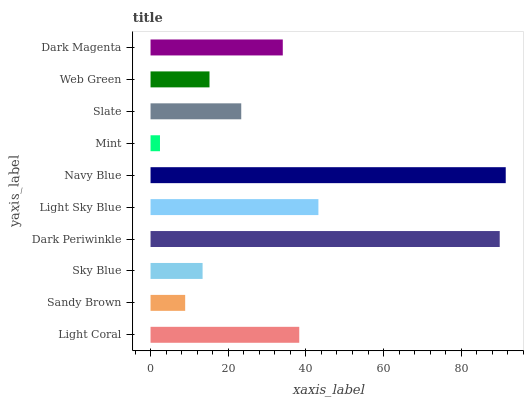Is Mint the minimum?
Answer yes or no. Yes. Is Navy Blue the maximum?
Answer yes or no. Yes. Is Sandy Brown the minimum?
Answer yes or no. No. Is Sandy Brown the maximum?
Answer yes or no. No. Is Light Coral greater than Sandy Brown?
Answer yes or no. Yes. Is Sandy Brown less than Light Coral?
Answer yes or no. Yes. Is Sandy Brown greater than Light Coral?
Answer yes or no. No. Is Light Coral less than Sandy Brown?
Answer yes or no. No. Is Dark Magenta the high median?
Answer yes or no. Yes. Is Slate the low median?
Answer yes or no. Yes. Is Web Green the high median?
Answer yes or no. No. Is Light Sky Blue the low median?
Answer yes or no. No. 